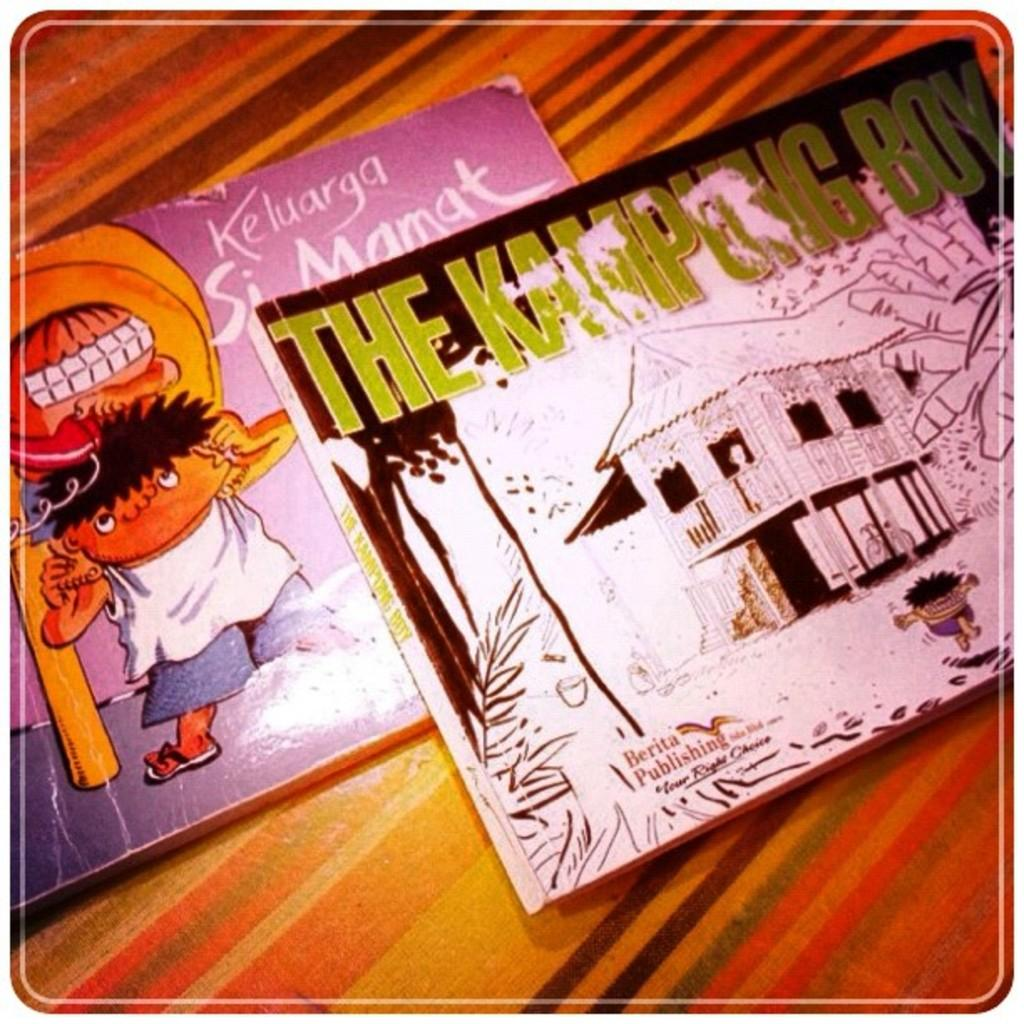<image>
Share a concise interpretation of the image provided. two childrens books called the kamping and lelugara 